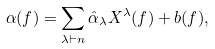Convert formula to latex. <formula><loc_0><loc_0><loc_500><loc_500>\alpha ( f ) = \sum _ { \lambda \vdash n } \hat { \alpha } _ { \lambda } X ^ { \lambda } ( f ) + b ( f ) ,</formula> 